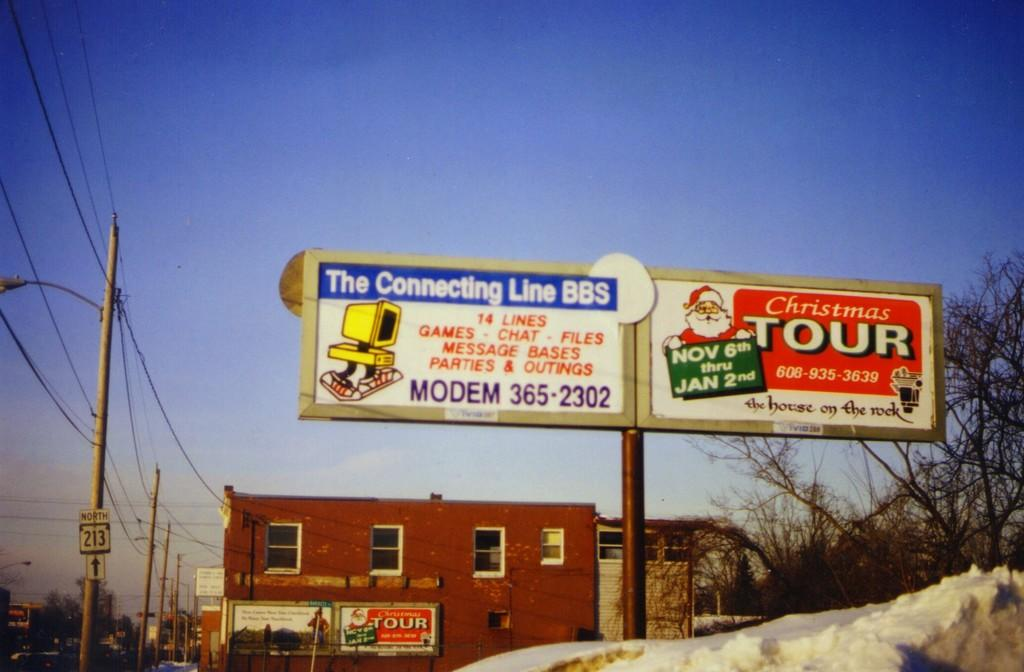Provide a one-sentence caption for the provided image. A building with an advertising sign for the Connecting Line BBS and Christmas Tours. 